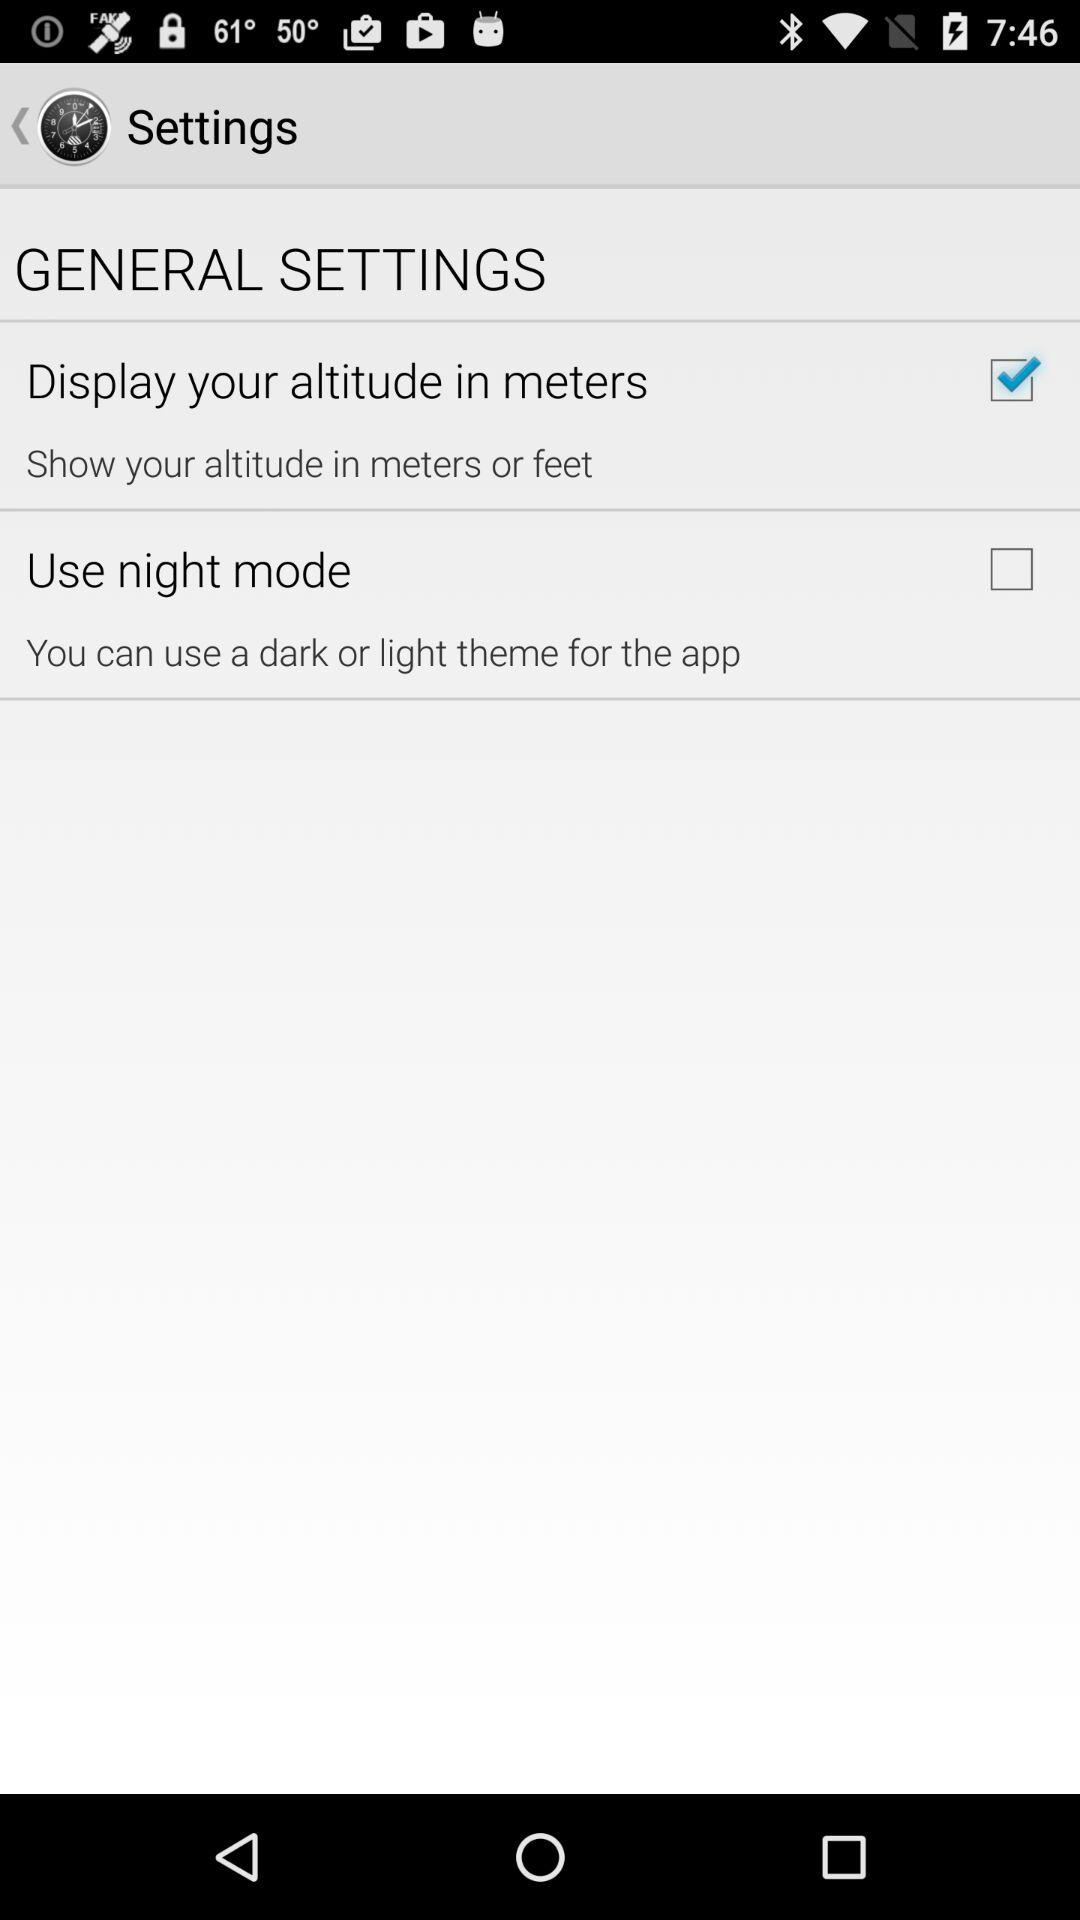Which option is checked in the general settings? The checked option is "Display your altitude in meters". 